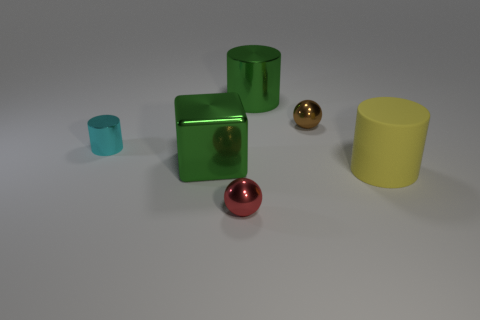What objects can you identify in the image? There are several objects including two cubes, one large and one small, a large cylinder, a small cup, and two spheres.  Can you tell me the colors of these objects? Certainly! The larger cube is green, the smaller one appears to be transparent or glass. The large cylinder is yellow, the small cup is also green, and the spheres are red and gold respectively.  Is there any pattern or theme to the arrangement of these objects? The objects seem to be arranged with no specific pattern. They are placed at varying distances from each other in a seemingly random configuration on a neutral background. 